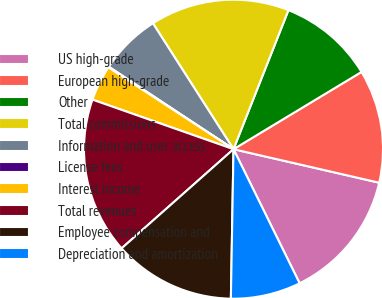Convert chart to OTSL. <chart><loc_0><loc_0><loc_500><loc_500><pie_chart><fcel>US high-grade<fcel>European high-grade<fcel>Other<fcel>Total commissions<fcel>Information and user access<fcel>License fees<fcel>Interest income<fcel>Total revenues<fcel>Employee compensation and<fcel>Depreciation and amortization<nl><fcel>14.11%<fcel>12.24%<fcel>10.37%<fcel>15.05%<fcel>6.64%<fcel>0.09%<fcel>3.83%<fcel>16.92%<fcel>13.18%<fcel>7.57%<nl></chart> 